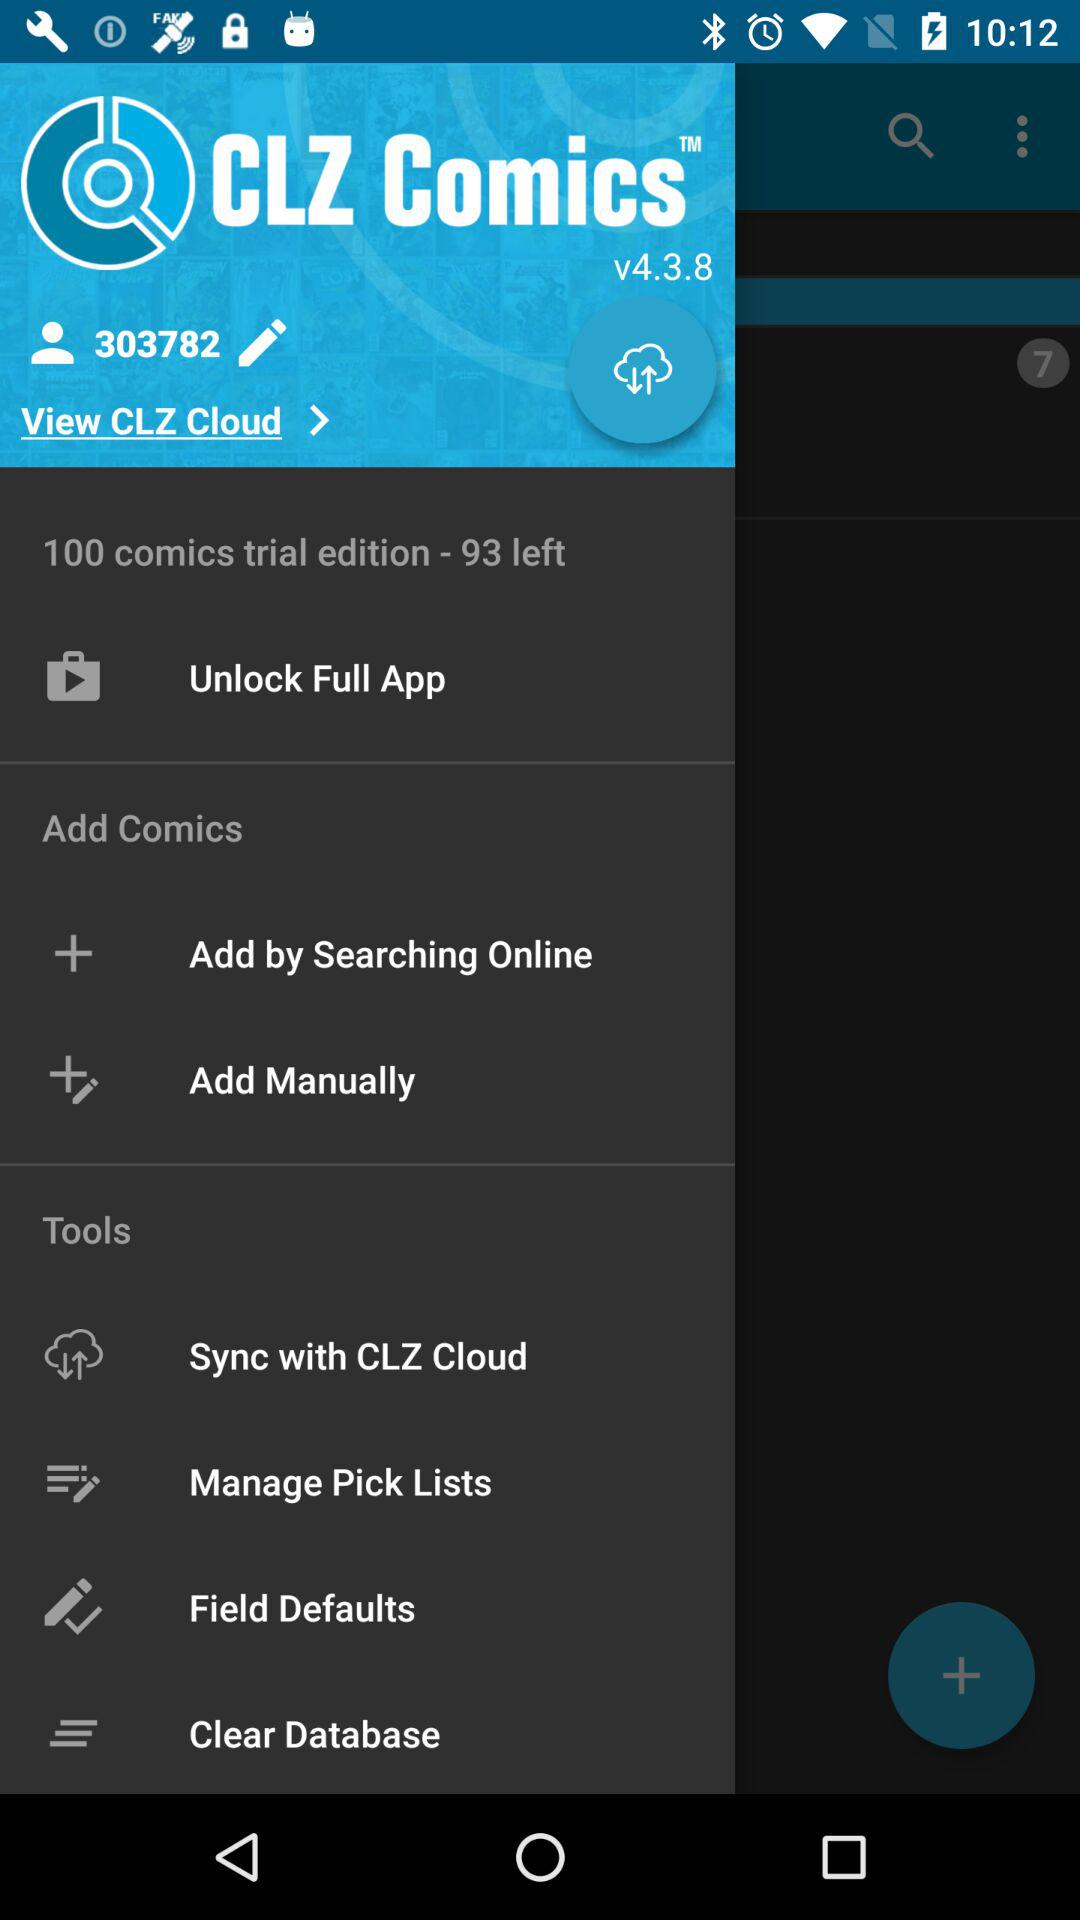How many comics are left in the trial version?
Answer the question using a single word or phrase. 93 